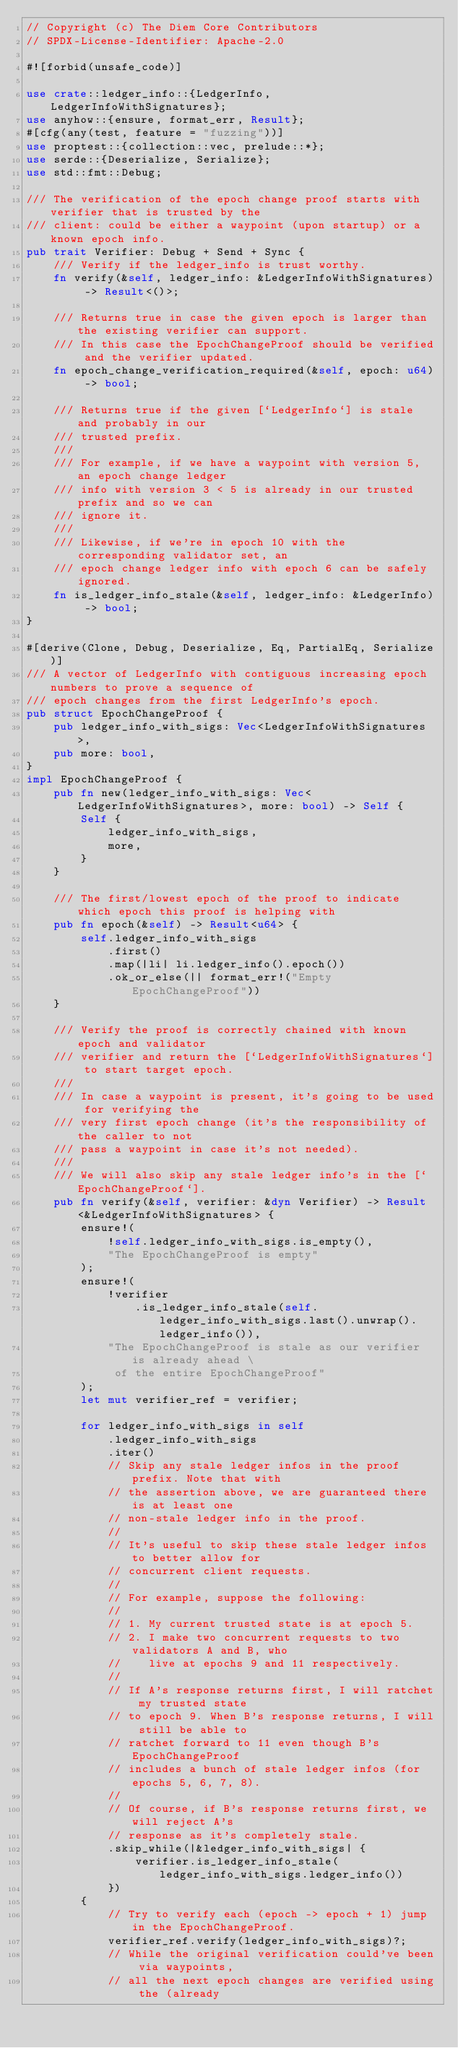<code> <loc_0><loc_0><loc_500><loc_500><_Rust_>// Copyright (c) The Diem Core Contributors
// SPDX-License-Identifier: Apache-2.0

#![forbid(unsafe_code)]

use crate::ledger_info::{LedgerInfo, LedgerInfoWithSignatures};
use anyhow::{ensure, format_err, Result};
#[cfg(any(test, feature = "fuzzing"))]
use proptest::{collection::vec, prelude::*};
use serde::{Deserialize, Serialize};
use std::fmt::Debug;

/// The verification of the epoch change proof starts with verifier that is trusted by the
/// client: could be either a waypoint (upon startup) or a known epoch info.
pub trait Verifier: Debug + Send + Sync {
    /// Verify if the ledger_info is trust worthy.
    fn verify(&self, ledger_info: &LedgerInfoWithSignatures) -> Result<()>;

    /// Returns true in case the given epoch is larger than the existing verifier can support.
    /// In this case the EpochChangeProof should be verified and the verifier updated.
    fn epoch_change_verification_required(&self, epoch: u64) -> bool;

    /// Returns true if the given [`LedgerInfo`] is stale and probably in our
    /// trusted prefix.
    ///
    /// For example, if we have a waypoint with version 5, an epoch change ledger
    /// info with version 3 < 5 is already in our trusted prefix and so we can
    /// ignore it.
    ///
    /// Likewise, if we're in epoch 10 with the corresponding validator set, an
    /// epoch change ledger info with epoch 6 can be safely ignored.
    fn is_ledger_info_stale(&self, ledger_info: &LedgerInfo) -> bool;
}

#[derive(Clone, Debug, Deserialize, Eq, PartialEq, Serialize)]
/// A vector of LedgerInfo with contiguous increasing epoch numbers to prove a sequence of
/// epoch changes from the first LedgerInfo's epoch.
pub struct EpochChangeProof {
    pub ledger_info_with_sigs: Vec<LedgerInfoWithSignatures>,
    pub more: bool,
}
impl EpochChangeProof {
    pub fn new(ledger_info_with_sigs: Vec<LedgerInfoWithSignatures>, more: bool) -> Self {
        Self {
            ledger_info_with_sigs,
            more,
        }
    }

    /// The first/lowest epoch of the proof to indicate which epoch this proof is helping with
    pub fn epoch(&self) -> Result<u64> {
        self.ledger_info_with_sigs
            .first()
            .map(|li| li.ledger_info().epoch())
            .ok_or_else(|| format_err!("Empty EpochChangeProof"))
    }

    /// Verify the proof is correctly chained with known epoch and validator
    /// verifier and return the [`LedgerInfoWithSignatures`] to start target epoch.
    ///
    /// In case a waypoint is present, it's going to be used for verifying the
    /// very first epoch change (it's the responsibility of the caller to not
    /// pass a waypoint in case it's not needed).
    ///
    /// We will also skip any stale ledger info's in the [`EpochChangeProof`].
    pub fn verify(&self, verifier: &dyn Verifier) -> Result<&LedgerInfoWithSignatures> {
        ensure!(
            !self.ledger_info_with_sigs.is_empty(),
            "The EpochChangeProof is empty"
        );
        ensure!(
            !verifier
                .is_ledger_info_stale(self.ledger_info_with_sigs.last().unwrap().ledger_info()),
            "The EpochChangeProof is stale as our verifier is already ahead \
             of the entire EpochChangeProof"
        );
        let mut verifier_ref = verifier;

        for ledger_info_with_sigs in self
            .ledger_info_with_sigs
            .iter()
            // Skip any stale ledger infos in the proof prefix. Note that with
            // the assertion above, we are guaranteed there is at least one
            // non-stale ledger info in the proof.
            //
            // It's useful to skip these stale ledger infos to better allow for
            // concurrent client requests.
            //
            // For example, suppose the following:
            //
            // 1. My current trusted state is at epoch 5.
            // 2. I make two concurrent requests to two validators A and B, who
            //    live at epochs 9 and 11 respectively.
            //
            // If A's response returns first, I will ratchet my trusted state
            // to epoch 9. When B's response returns, I will still be able to
            // ratchet forward to 11 even though B's EpochChangeProof
            // includes a bunch of stale ledger infos (for epochs 5, 6, 7, 8).
            //
            // Of course, if B's response returns first, we will reject A's
            // response as it's completely stale.
            .skip_while(|&ledger_info_with_sigs| {
                verifier.is_ledger_info_stale(ledger_info_with_sigs.ledger_info())
            })
        {
            // Try to verify each (epoch -> epoch + 1) jump in the EpochChangeProof.
            verifier_ref.verify(ledger_info_with_sigs)?;
            // While the original verification could've been via waypoints,
            // all the next epoch changes are verified using the (already</code> 